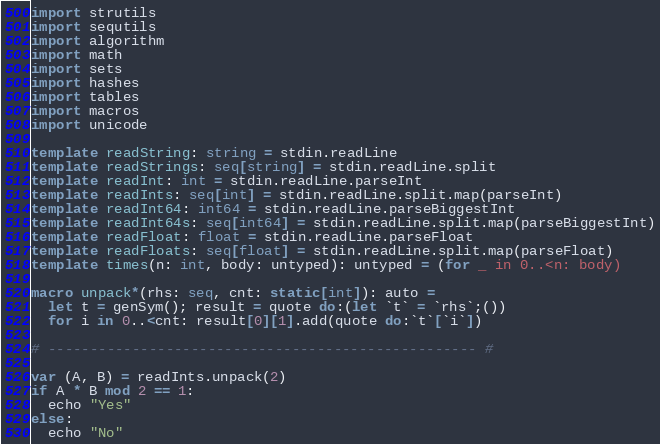Convert code to text. <code><loc_0><loc_0><loc_500><loc_500><_Nim_>import strutils
import sequtils
import algorithm
import math
import sets
import hashes
import tables
import macros
import unicode

template readString: string = stdin.readLine
template readStrings: seq[string] = stdin.readLine.split
template readInt: int = stdin.readLine.parseInt
template readInts: seq[int] = stdin.readLine.split.map(parseInt)
template readInt64: int64 = stdin.readLine.parseBiggestInt
template readInt64s: seq[int64] = stdin.readLine.split.map(parseBiggestInt)
template readFloat: float = stdin.readLine.parseFloat
template readFloats: seq[float] = stdin.readLine.split.map(parseFloat)
template times(n: int, body: untyped): untyped = (for _ in 0..<n: body)

macro unpack*(rhs: seq, cnt: static[int]): auto =
  let t = genSym(); result = quote do:(let `t` = `rhs`;())
  for i in 0..<cnt: result[0][1].add(quote do:`t`[`i`])

# --------------------------------------------------- #

var (A, B) = readInts.unpack(2)
if A * B mod 2 == 1:
  echo "Yes"
else:
  echo "No"</code> 